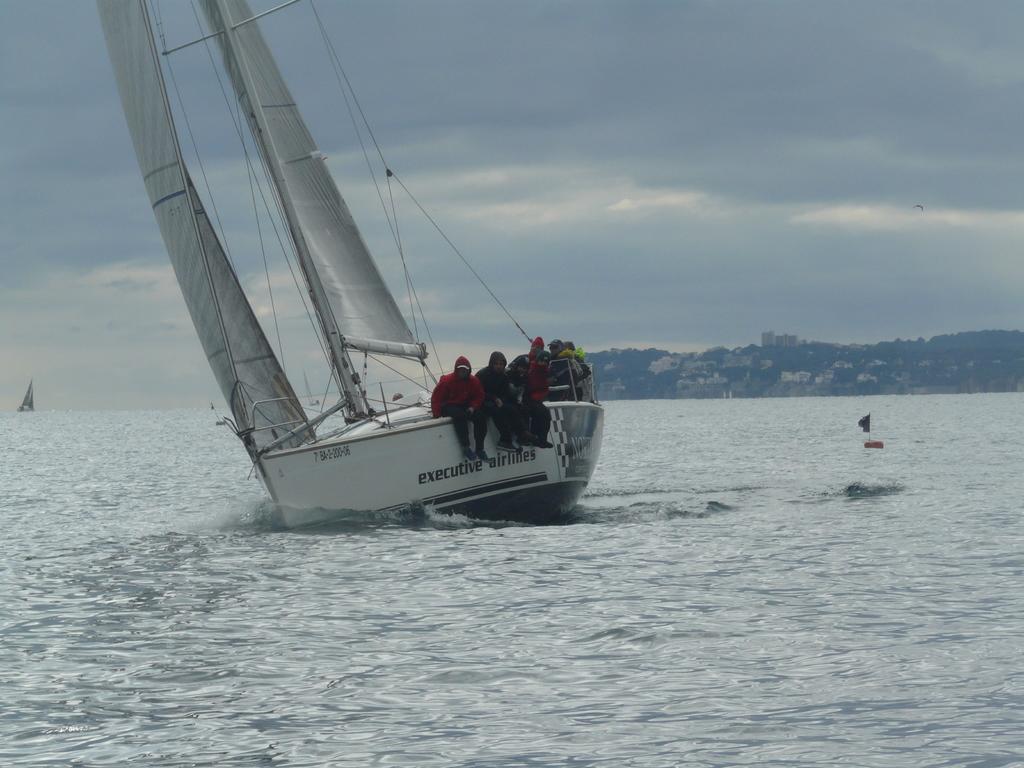Please provide a concise description of this image. In this image we can see some group of persons sitting in trireme is off white color which is moving on water and in the background of the image there are some houses, trees and top of the image there is cloudy sky. 